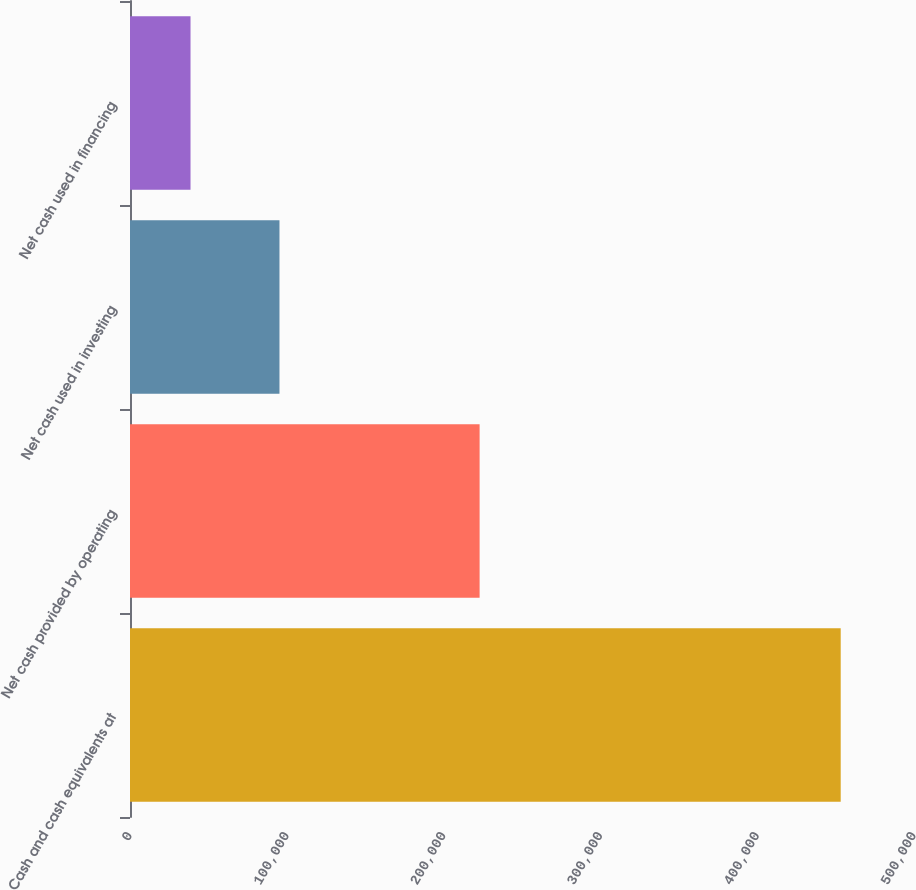Convert chart to OTSL. <chart><loc_0><loc_0><loc_500><loc_500><bar_chart><fcel>Cash and cash equivalents at<fcel>Net cash provided by operating<fcel>Net cash used in investing<fcel>Net cash used in financing<nl><fcel>453257<fcel>222962<fcel>95329<fcel>38597<nl></chart> 